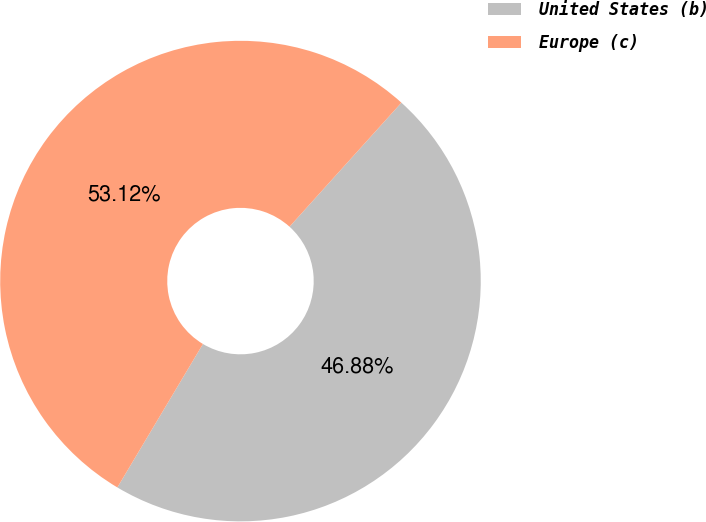Convert chart. <chart><loc_0><loc_0><loc_500><loc_500><pie_chart><fcel>United States (b)<fcel>Europe (c)<nl><fcel>46.88%<fcel>53.12%<nl></chart> 